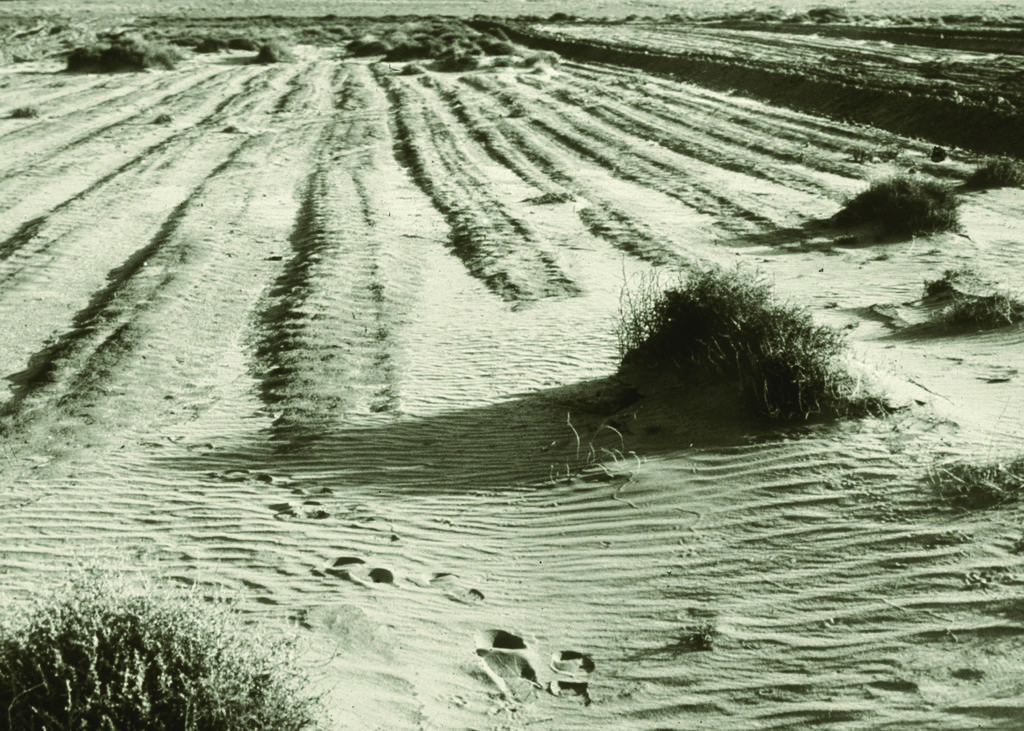What type of living organisms can be seen in the image? Plants can be seen in the image. Where are the plants located in relation to the ground? The plants are on the ground. What is the value of the ear in the image? There is no ear present in the image, so it is not possible to determine its value. 